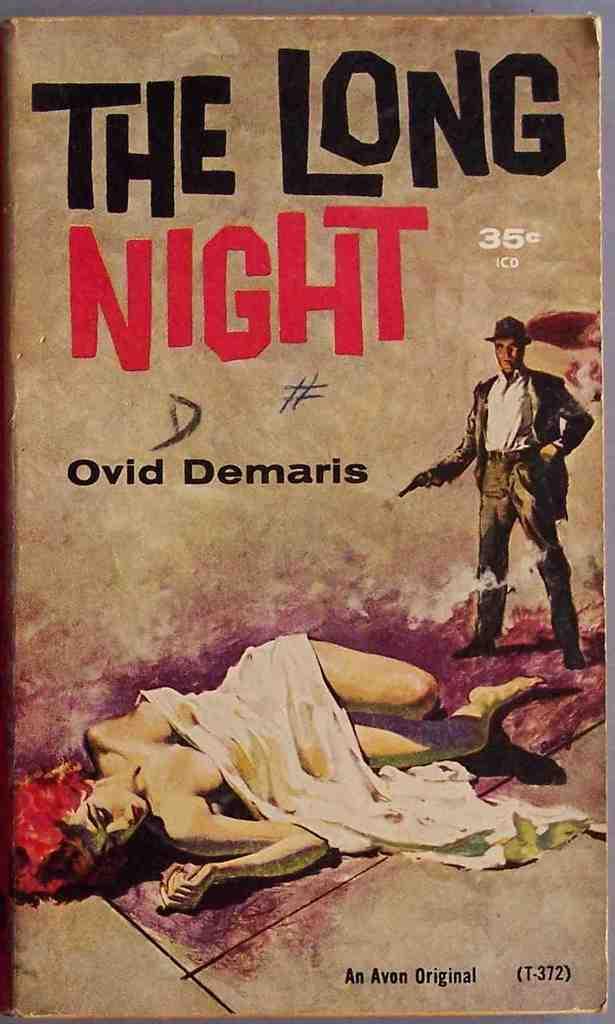Who is the author of the book the long night?
Make the answer very short. Ovid demaris. How much did this book cost?
Provide a short and direct response. 35 cents. 